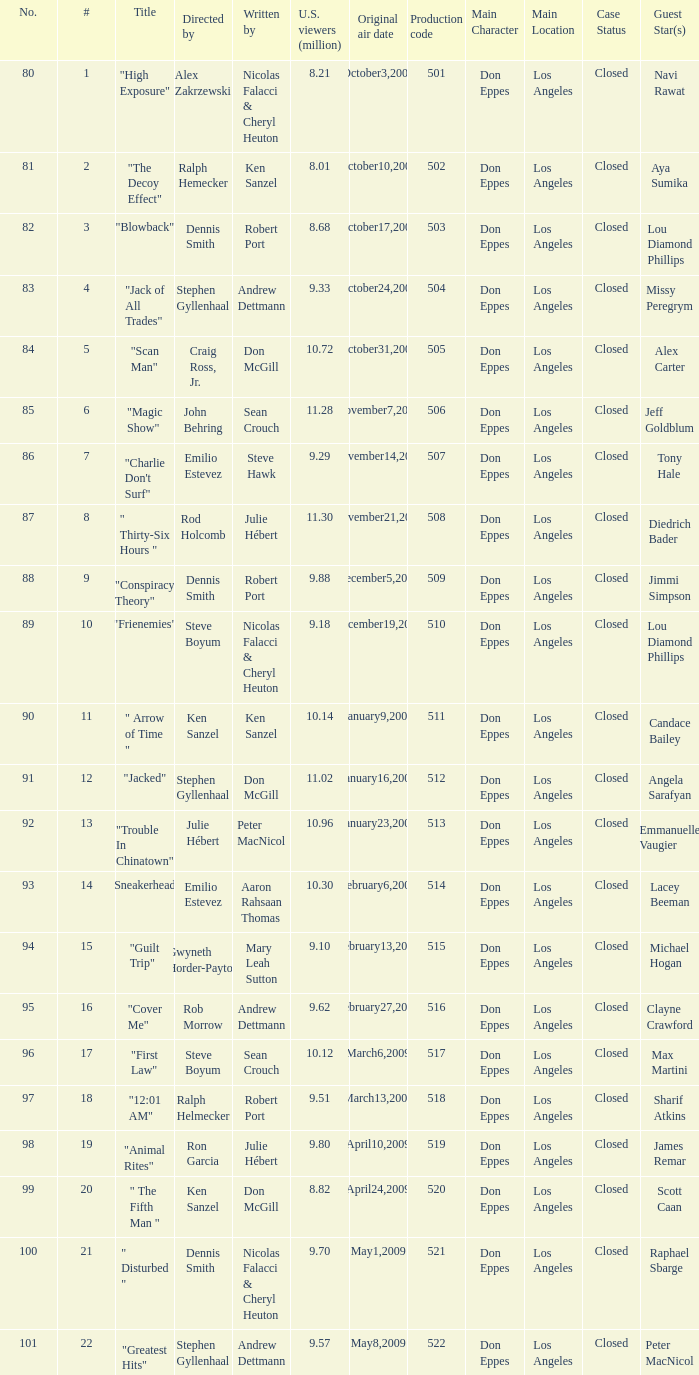Who wrote the episode with the production code 519? Julie Hébert. 